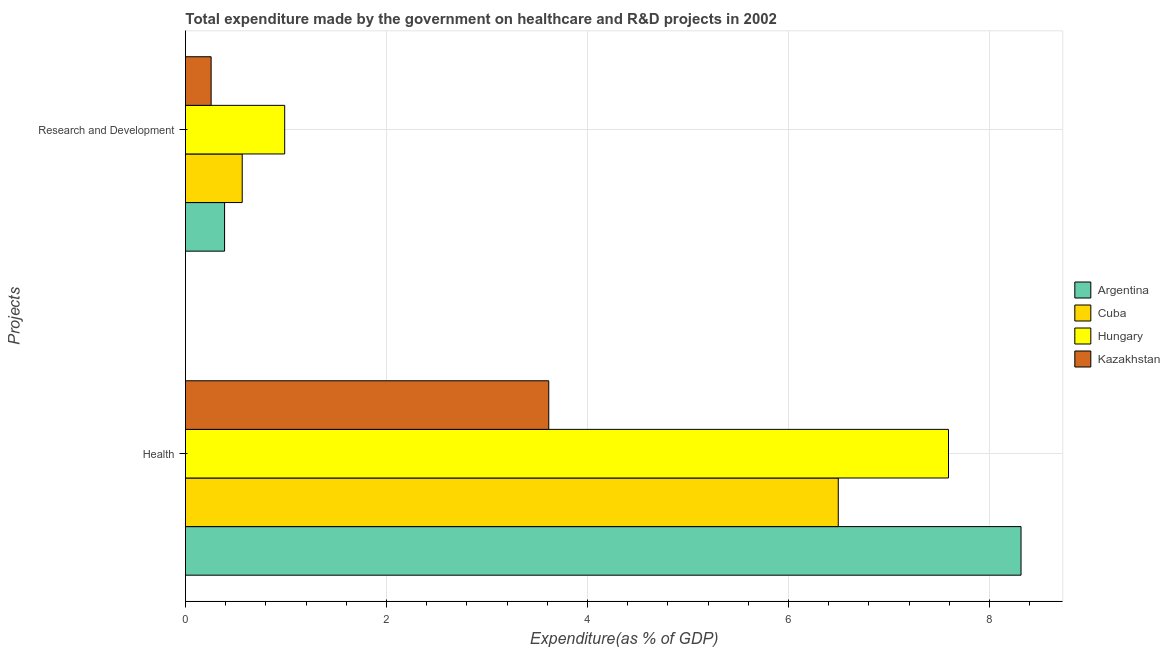How many different coloured bars are there?
Provide a short and direct response. 4. What is the label of the 2nd group of bars from the top?
Offer a terse response. Health. What is the expenditure in healthcare in Hungary?
Your response must be concise. 7.59. Across all countries, what is the maximum expenditure in r&d?
Offer a terse response. 0.99. Across all countries, what is the minimum expenditure in r&d?
Your answer should be very brief. 0.26. In which country was the expenditure in r&d maximum?
Give a very brief answer. Hungary. In which country was the expenditure in r&d minimum?
Your answer should be compact. Kazakhstan. What is the total expenditure in healthcare in the graph?
Provide a succinct answer. 26.02. What is the difference between the expenditure in r&d in Hungary and that in Argentina?
Offer a terse response. 0.6. What is the difference between the expenditure in r&d in Kazakhstan and the expenditure in healthcare in Argentina?
Offer a terse response. -8.06. What is the average expenditure in r&d per country?
Offer a very short reply. 0.55. What is the difference between the expenditure in r&d and expenditure in healthcare in Hungary?
Provide a succinct answer. -6.61. In how many countries, is the expenditure in r&d greater than 4.8 %?
Ensure brevity in your answer.  0. What is the ratio of the expenditure in healthcare in Kazakhstan to that in Cuba?
Ensure brevity in your answer.  0.56. Is the expenditure in r&d in Hungary less than that in Cuba?
Give a very brief answer. No. What does the 1st bar from the top in Health represents?
Make the answer very short. Kazakhstan. What does the 1st bar from the bottom in Health represents?
Your answer should be very brief. Argentina. How many countries are there in the graph?
Your answer should be compact. 4. What is the difference between two consecutive major ticks on the X-axis?
Give a very brief answer. 2. Does the graph contain grids?
Provide a succinct answer. Yes. How are the legend labels stacked?
Your answer should be compact. Vertical. What is the title of the graph?
Your answer should be very brief. Total expenditure made by the government on healthcare and R&D projects in 2002. Does "Tajikistan" appear as one of the legend labels in the graph?
Offer a terse response. No. What is the label or title of the X-axis?
Your answer should be very brief. Expenditure(as % of GDP). What is the label or title of the Y-axis?
Keep it short and to the point. Projects. What is the Expenditure(as % of GDP) in Argentina in Health?
Give a very brief answer. 8.31. What is the Expenditure(as % of GDP) of Cuba in Health?
Offer a terse response. 6.5. What is the Expenditure(as % of GDP) in Hungary in Health?
Provide a succinct answer. 7.59. What is the Expenditure(as % of GDP) in Kazakhstan in Health?
Your answer should be compact. 3.61. What is the Expenditure(as % of GDP) in Argentina in Research and Development?
Provide a succinct answer. 0.39. What is the Expenditure(as % of GDP) of Cuba in Research and Development?
Your answer should be compact. 0.56. What is the Expenditure(as % of GDP) of Hungary in Research and Development?
Give a very brief answer. 0.99. What is the Expenditure(as % of GDP) of Kazakhstan in Research and Development?
Keep it short and to the point. 0.26. Across all Projects, what is the maximum Expenditure(as % of GDP) of Argentina?
Give a very brief answer. 8.31. Across all Projects, what is the maximum Expenditure(as % of GDP) of Cuba?
Your answer should be very brief. 6.5. Across all Projects, what is the maximum Expenditure(as % of GDP) in Hungary?
Your answer should be very brief. 7.59. Across all Projects, what is the maximum Expenditure(as % of GDP) of Kazakhstan?
Make the answer very short. 3.61. Across all Projects, what is the minimum Expenditure(as % of GDP) in Argentina?
Your response must be concise. 0.39. Across all Projects, what is the minimum Expenditure(as % of GDP) of Cuba?
Make the answer very short. 0.56. Across all Projects, what is the minimum Expenditure(as % of GDP) in Hungary?
Keep it short and to the point. 0.99. Across all Projects, what is the minimum Expenditure(as % of GDP) in Kazakhstan?
Provide a succinct answer. 0.26. What is the total Expenditure(as % of GDP) of Argentina in the graph?
Your answer should be compact. 8.7. What is the total Expenditure(as % of GDP) of Cuba in the graph?
Your answer should be very brief. 7.06. What is the total Expenditure(as % of GDP) in Hungary in the graph?
Your response must be concise. 8.58. What is the total Expenditure(as % of GDP) in Kazakhstan in the graph?
Provide a succinct answer. 3.87. What is the difference between the Expenditure(as % of GDP) of Argentina in Health and that in Research and Development?
Provide a succinct answer. 7.93. What is the difference between the Expenditure(as % of GDP) in Cuba in Health and that in Research and Development?
Your response must be concise. 5.93. What is the difference between the Expenditure(as % of GDP) in Hungary in Health and that in Research and Development?
Ensure brevity in your answer.  6.61. What is the difference between the Expenditure(as % of GDP) in Kazakhstan in Health and that in Research and Development?
Give a very brief answer. 3.36. What is the difference between the Expenditure(as % of GDP) of Argentina in Health and the Expenditure(as % of GDP) of Cuba in Research and Development?
Offer a very short reply. 7.75. What is the difference between the Expenditure(as % of GDP) of Argentina in Health and the Expenditure(as % of GDP) of Hungary in Research and Development?
Keep it short and to the point. 7.33. What is the difference between the Expenditure(as % of GDP) in Argentina in Health and the Expenditure(as % of GDP) in Kazakhstan in Research and Development?
Ensure brevity in your answer.  8.06. What is the difference between the Expenditure(as % of GDP) in Cuba in Health and the Expenditure(as % of GDP) in Hungary in Research and Development?
Your answer should be compact. 5.51. What is the difference between the Expenditure(as % of GDP) in Cuba in Health and the Expenditure(as % of GDP) in Kazakhstan in Research and Development?
Ensure brevity in your answer.  6.24. What is the difference between the Expenditure(as % of GDP) of Hungary in Health and the Expenditure(as % of GDP) of Kazakhstan in Research and Development?
Your answer should be compact. 7.34. What is the average Expenditure(as % of GDP) in Argentina per Projects?
Make the answer very short. 4.35. What is the average Expenditure(as % of GDP) of Cuba per Projects?
Make the answer very short. 3.53. What is the average Expenditure(as % of GDP) in Hungary per Projects?
Your response must be concise. 4.29. What is the average Expenditure(as % of GDP) in Kazakhstan per Projects?
Provide a short and direct response. 1.93. What is the difference between the Expenditure(as % of GDP) in Argentina and Expenditure(as % of GDP) in Cuba in Health?
Provide a succinct answer. 1.82. What is the difference between the Expenditure(as % of GDP) of Argentina and Expenditure(as % of GDP) of Hungary in Health?
Provide a succinct answer. 0.72. What is the difference between the Expenditure(as % of GDP) of Argentina and Expenditure(as % of GDP) of Kazakhstan in Health?
Give a very brief answer. 4.7. What is the difference between the Expenditure(as % of GDP) in Cuba and Expenditure(as % of GDP) in Hungary in Health?
Offer a very short reply. -1.1. What is the difference between the Expenditure(as % of GDP) in Cuba and Expenditure(as % of GDP) in Kazakhstan in Health?
Give a very brief answer. 2.88. What is the difference between the Expenditure(as % of GDP) in Hungary and Expenditure(as % of GDP) in Kazakhstan in Health?
Make the answer very short. 3.98. What is the difference between the Expenditure(as % of GDP) in Argentina and Expenditure(as % of GDP) in Cuba in Research and Development?
Make the answer very short. -0.18. What is the difference between the Expenditure(as % of GDP) in Argentina and Expenditure(as % of GDP) in Hungary in Research and Development?
Provide a short and direct response. -0.6. What is the difference between the Expenditure(as % of GDP) of Argentina and Expenditure(as % of GDP) of Kazakhstan in Research and Development?
Provide a short and direct response. 0.13. What is the difference between the Expenditure(as % of GDP) in Cuba and Expenditure(as % of GDP) in Hungary in Research and Development?
Make the answer very short. -0.42. What is the difference between the Expenditure(as % of GDP) of Cuba and Expenditure(as % of GDP) of Kazakhstan in Research and Development?
Provide a short and direct response. 0.31. What is the difference between the Expenditure(as % of GDP) of Hungary and Expenditure(as % of GDP) of Kazakhstan in Research and Development?
Give a very brief answer. 0.73. What is the ratio of the Expenditure(as % of GDP) of Argentina in Health to that in Research and Development?
Offer a very short reply. 21.38. What is the ratio of the Expenditure(as % of GDP) in Cuba in Health to that in Research and Development?
Keep it short and to the point. 11.51. What is the ratio of the Expenditure(as % of GDP) in Hungary in Health to that in Research and Development?
Ensure brevity in your answer.  7.69. What is the ratio of the Expenditure(as % of GDP) in Kazakhstan in Health to that in Research and Development?
Provide a succinct answer. 14.17. What is the difference between the highest and the second highest Expenditure(as % of GDP) of Argentina?
Offer a very short reply. 7.93. What is the difference between the highest and the second highest Expenditure(as % of GDP) in Cuba?
Your response must be concise. 5.93. What is the difference between the highest and the second highest Expenditure(as % of GDP) of Hungary?
Your answer should be compact. 6.61. What is the difference between the highest and the second highest Expenditure(as % of GDP) in Kazakhstan?
Give a very brief answer. 3.36. What is the difference between the highest and the lowest Expenditure(as % of GDP) of Argentina?
Your response must be concise. 7.93. What is the difference between the highest and the lowest Expenditure(as % of GDP) of Cuba?
Provide a succinct answer. 5.93. What is the difference between the highest and the lowest Expenditure(as % of GDP) in Hungary?
Keep it short and to the point. 6.61. What is the difference between the highest and the lowest Expenditure(as % of GDP) of Kazakhstan?
Offer a very short reply. 3.36. 